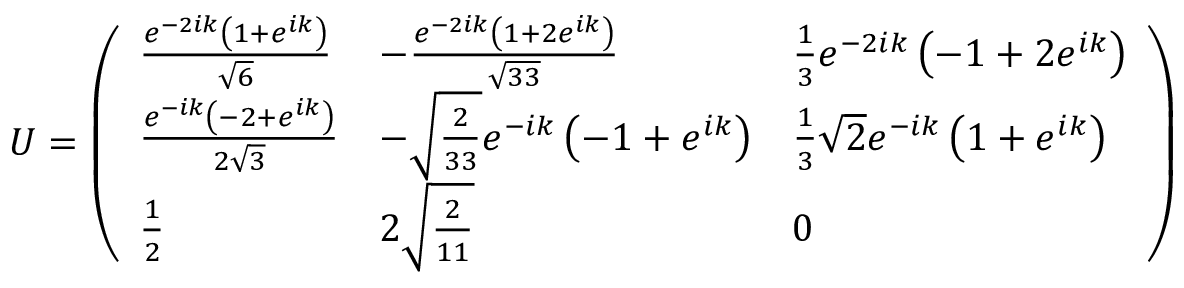Convert formula to latex. <formula><loc_0><loc_0><loc_500><loc_500>\begin{array} { r } { U = \left ( \begin{array} { l l l } { \frac { e ^ { - 2 i k } \left ( 1 + e ^ { i k } \right ) } { \sqrt { 6 } } } & { - \frac { e ^ { - 2 i k } \left ( 1 + 2 e ^ { i k } \right ) } { \sqrt { 3 3 } } } & { \frac { 1 } { 3 } e ^ { - 2 i k } \left ( - 1 + 2 e ^ { i k } \right ) } \\ { \frac { e ^ { - i k } \left ( - 2 + e ^ { i k } \right ) } { 2 \sqrt { 3 } } } & { - \sqrt { \frac { 2 } { 3 3 } } e ^ { - i k } \left ( - 1 + e ^ { i k } \right ) } & { \frac { 1 } { 3 } \sqrt { 2 } e ^ { - i k } \left ( 1 + e ^ { i k } \right ) } \\ { \frac { 1 } { 2 } } & { 2 \sqrt { \frac { 2 } { 1 1 } } } & { 0 } \end{array} \right ) } \end{array}</formula> 